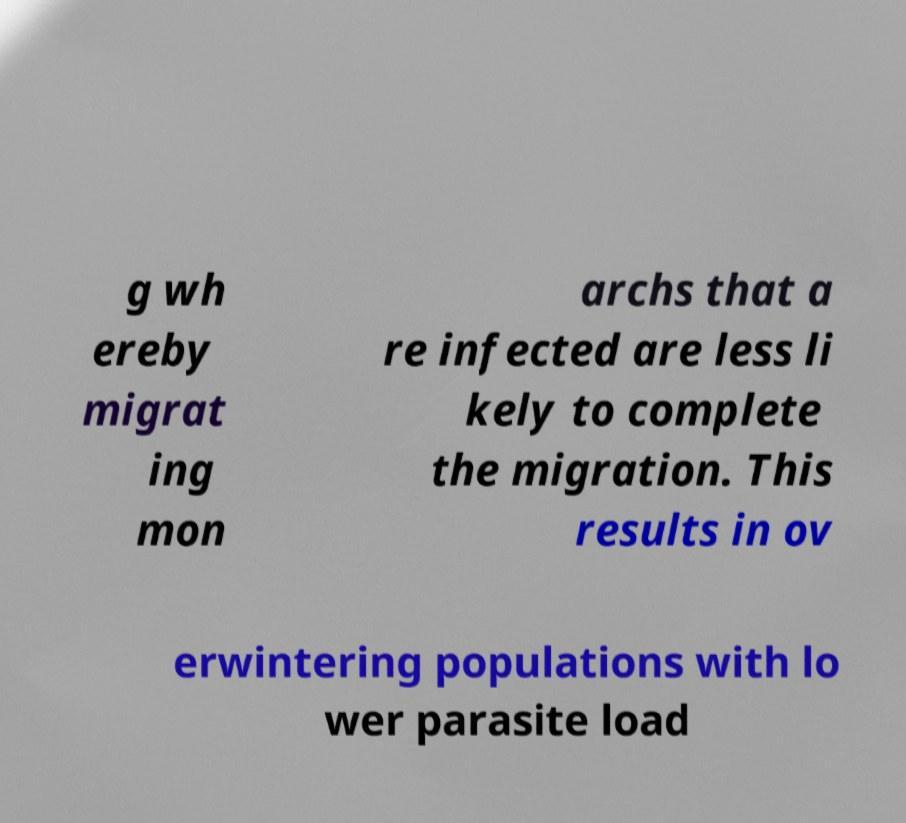Could you extract and type out the text from this image? g wh ereby migrat ing mon archs that a re infected are less li kely to complete the migration. This results in ov erwintering populations with lo wer parasite load 